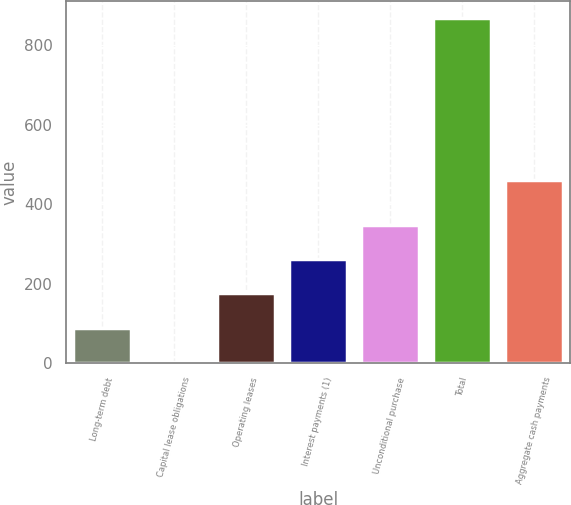Convert chart. <chart><loc_0><loc_0><loc_500><loc_500><bar_chart><fcel>Long-term debt<fcel>Capital lease obligations<fcel>Operating leases<fcel>Interest payments (1)<fcel>Unconditional purchase<fcel>Total<fcel>Aggregate cash payments<nl><fcel>88.6<fcel>2<fcel>175.2<fcel>261.8<fcel>348.4<fcel>868<fcel>462<nl></chart> 